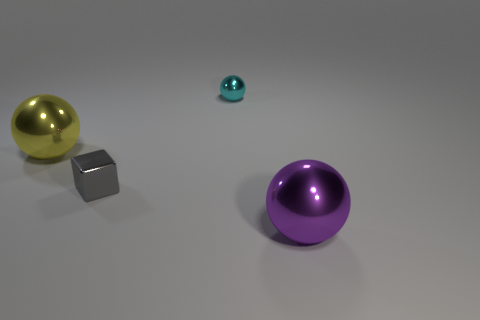Is the number of large purple balls that are on the right side of the large purple shiny ball less than the number of large gray shiny cubes? Actually, in the image provided, there is only one large purple shiny ball, and it is centrally located rather than on the right side of any others. Additionally, there is only one large gray shiny cube present. Since there aren't multiple large purple balls or gray cubes to compare, as the question suggests, the answer is that the premise of the question is not applicable to the content of the image. 